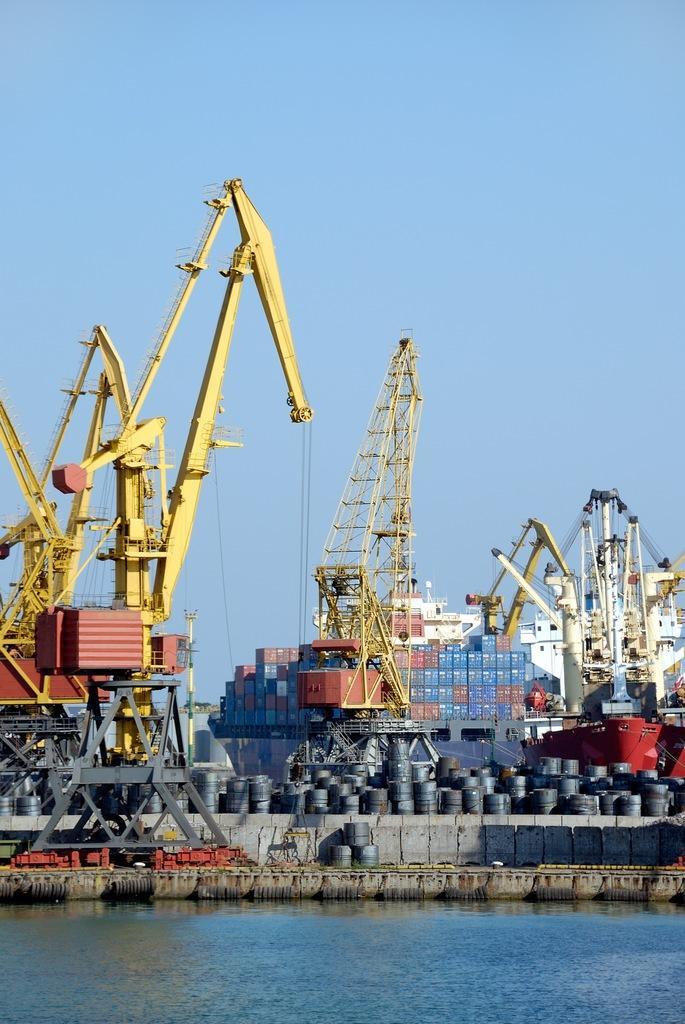Please provide a concise description of this image. I think this picture was taken in the port. These are the cranes. I can see the iron containers. I think these are the iron barrels. Here is the water flowing. This looks like a ship. 